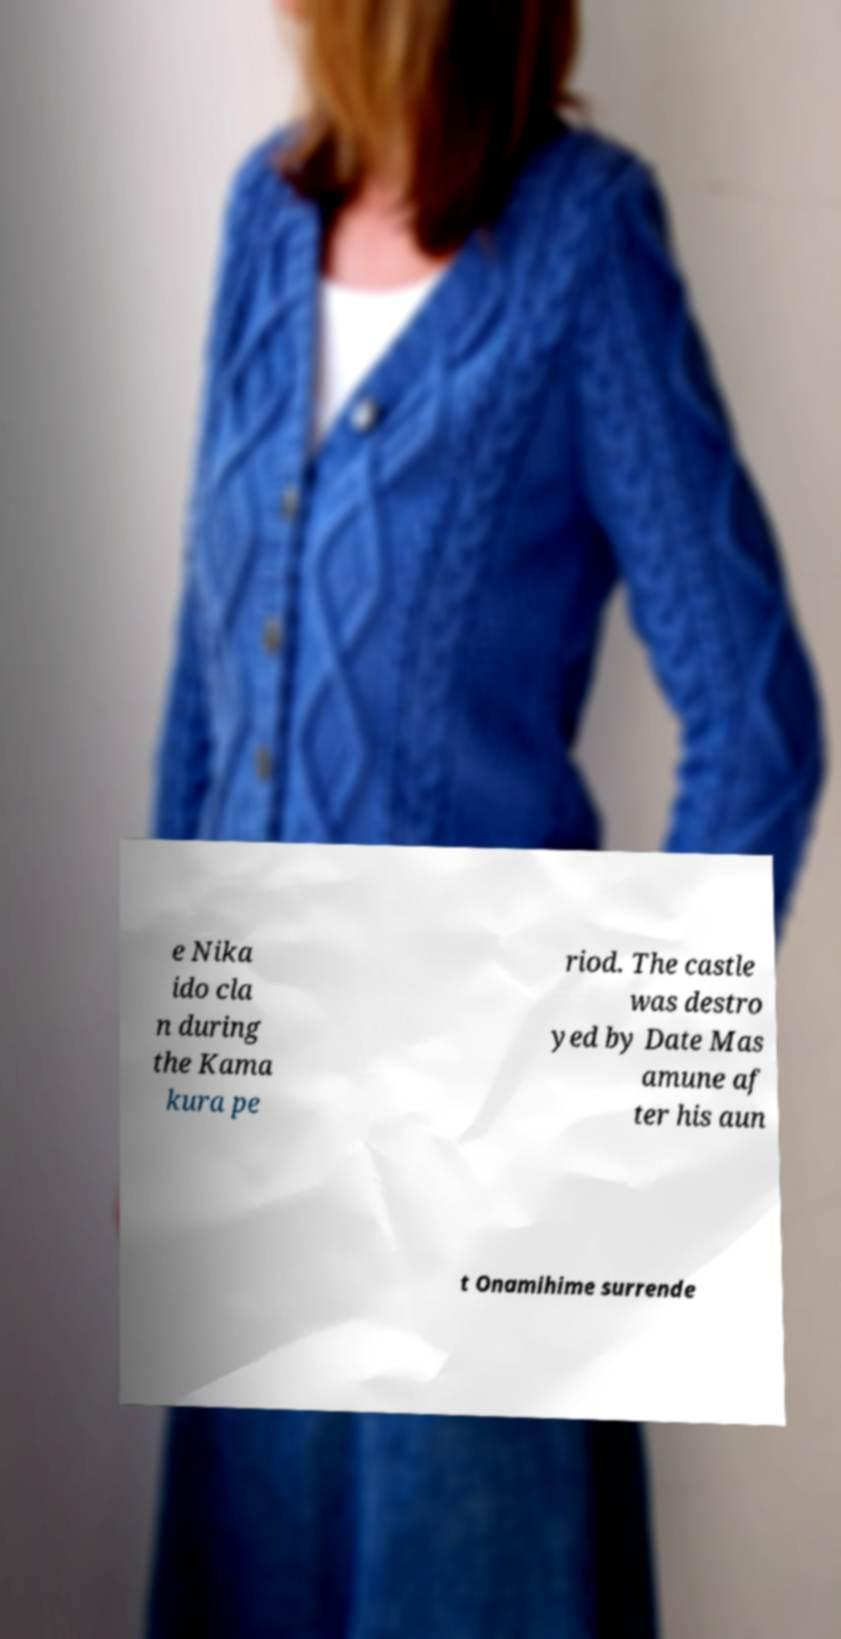I need the written content from this picture converted into text. Can you do that? e Nika ido cla n during the Kama kura pe riod. The castle was destro yed by Date Mas amune af ter his aun t Onamihime surrende 